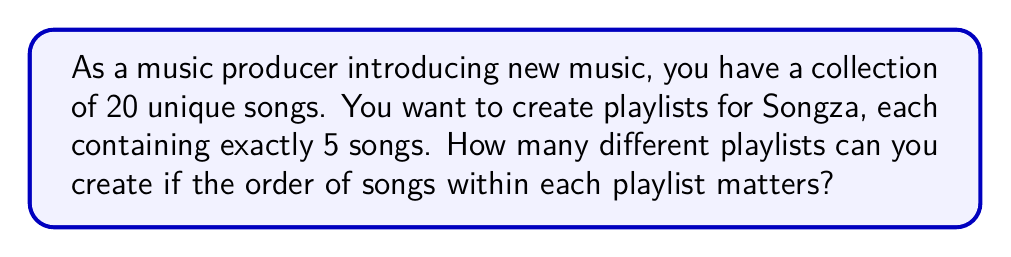Solve this math problem. To solve this problem, we need to use the concept of permutations. Here's a step-by-step explanation:

1) We are selecting 5 songs out of 20, and the order matters (since the sequence of songs in a playlist is important).

2) This scenario is a permutation without repetition, as we don't want to repeat songs in a single playlist.

3) The formula for permutations without repetition is:

   $$P(n,r) = \frac{n!}{(n-r)!}$$

   Where $n$ is the total number of items to choose from, and $r$ is the number of items being chosen.

4) In this case, $n = 20$ (total songs) and $r = 5$ (songs per playlist).

5) Plugging these values into our formula:

   $$P(20,5) = \frac{20!}{(20-5)!} = \frac{20!}{15!}$$

6) Expanding this:
   
   $$\frac{20 * 19 * 18 * 17 * 16 * 15!}{15!}$$

7) The 15! cancels out in the numerator and denominator:

   $$20 * 19 * 18 * 17 * 16 = 1,860,480$$

Therefore, you can create 1,860,480 unique playlists.
Answer: 1,860,480 